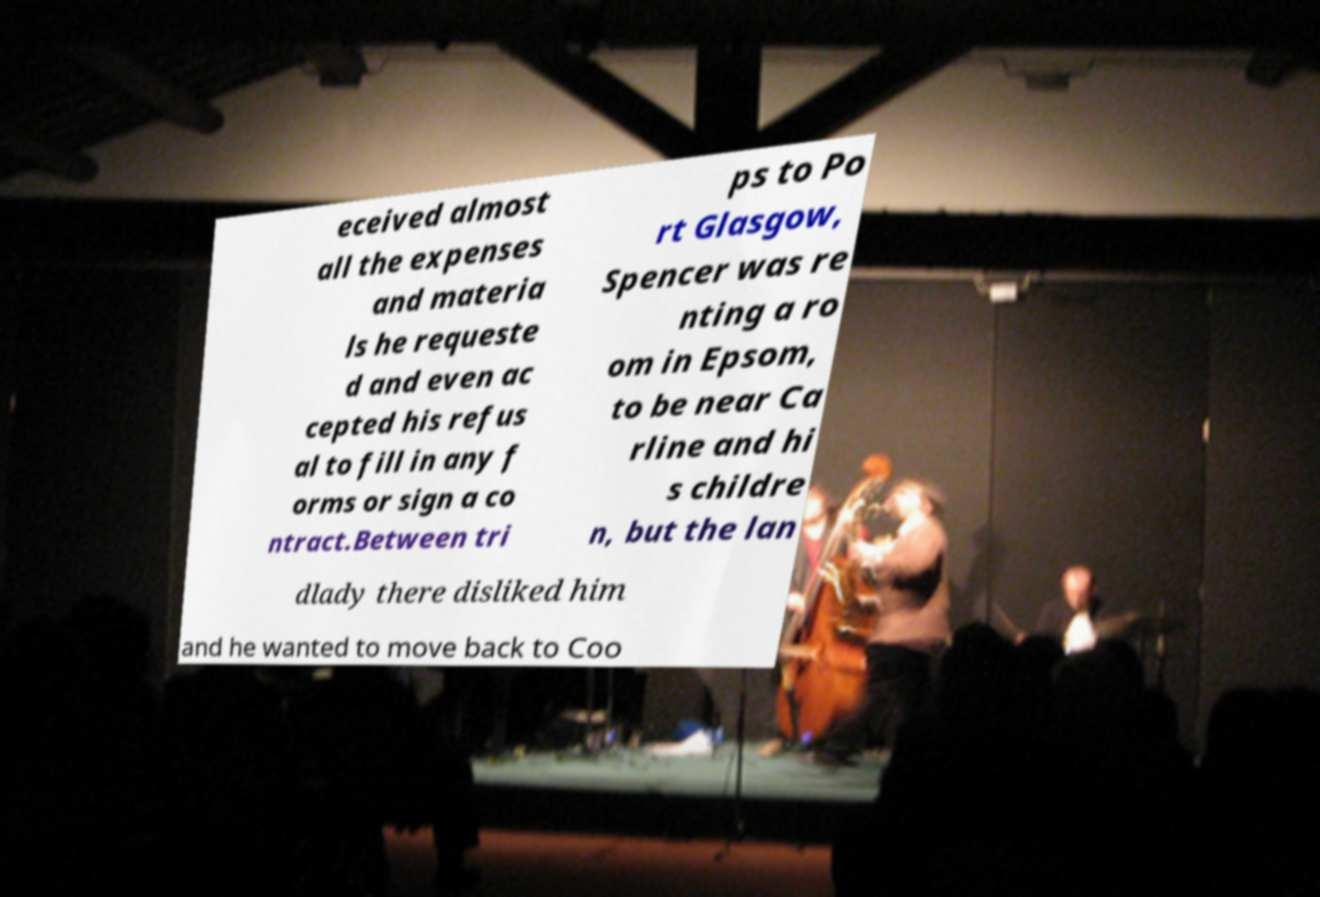Can you accurately transcribe the text from the provided image for me? eceived almost all the expenses and materia ls he requeste d and even ac cepted his refus al to fill in any f orms or sign a co ntract.Between tri ps to Po rt Glasgow, Spencer was re nting a ro om in Epsom, to be near Ca rline and hi s childre n, but the lan dlady there disliked him and he wanted to move back to Coo 